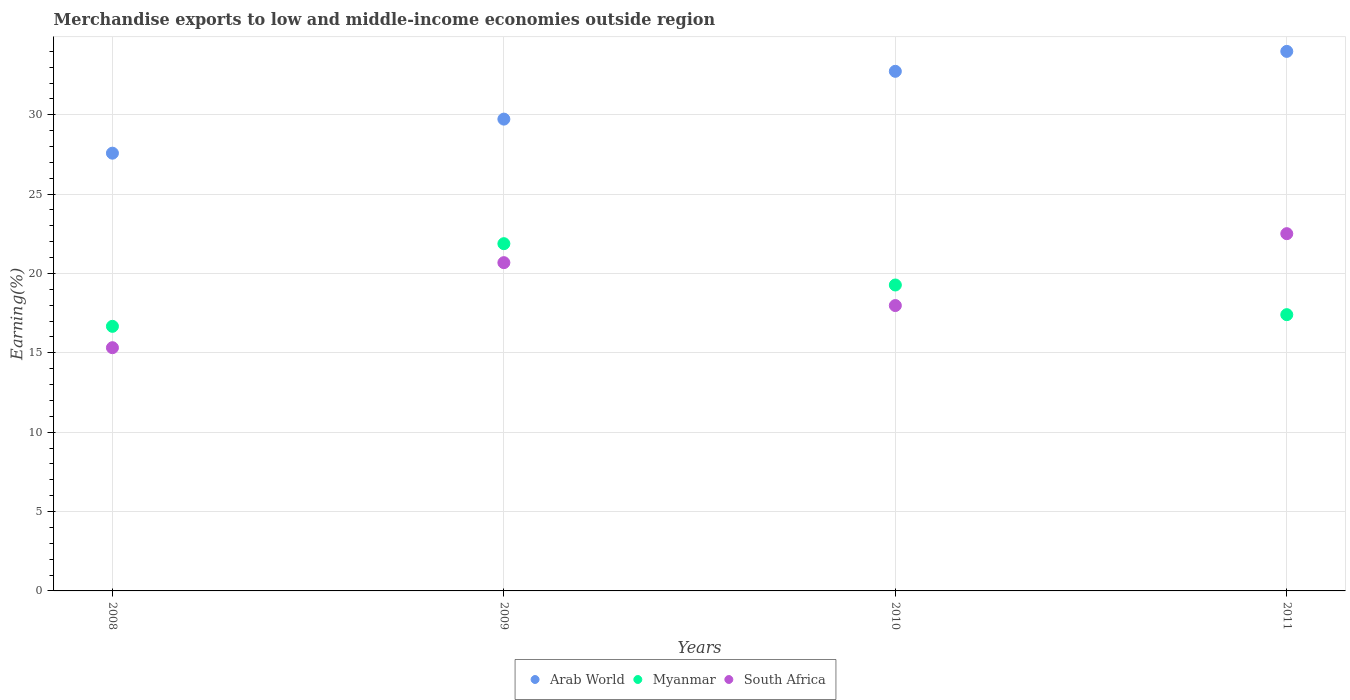Is the number of dotlines equal to the number of legend labels?
Give a very brief answer. Yes. What is the percentage of amount earned from merchandise exports in Myanmar in 2011?
Make the answer very short. 17.41. Across all years, what is the maximum percentage of amount earned from merchandise exports in Arab World?
Your answer should be compact. 33.99. Across all years, what is the minimum percentage of amount earned from merchandise exports in Myanmar?
Offer a terse response. 16.67. In which year was the percentage of amount earned from merchandise exports in Arab World minimum?
Your response must be concise. 2008. What is the total percentage of amount earned from merchandise exports in Arab World in the graph?
Ensure brevity in your answer.  124.03. What is the difference between the percentage of amount earned from merchandise exports in Myanmar in 2009 and that in 2010?
Offer a terse response. 2.6. What is the difference between the percentage of amount earned from merchandise exports in South Africa in 2009 and the percentage of amount earned from merchandise exports in Arab World in 2008?
Make the answer very short. -6.9. What is the average percentage of amount earned from merchandise exports in Arab World per year?
Provide a succinct answer. 31.01. In the year 2010, what is the difference between the percentage of amount earned from merchandise exports in Myanmar and percentage of amount earned from merchandise exports in Arab World?
Ensure brevity in your answer.  -13.46. What is the ratio of the percentage of amount earned from merchandise exports in Arab World in 2008 to that in 2009?
Provide a short and direct response. 0.93. What is the difference between the highest and the second highest percentage of amount earned from merchandise exports in Arab World?
Your response must be concise. 1.26. What is the difference between the highest and the lowest percentage of amount earned from merchandise exports in Arab World?
Provide a succinct answer. 6.41. In how many years, is the percentage of amount earned from merchandise exports in Arab World greater than the average percentage of amount earned from merchandise exports in Arab World taken over all years?
Give a very brief answer. 2. Is the sum of the percentage of amount earned from merchandise exports in Myanmar in 2008 and 2009 greater than the maximum percentage of amount earned from merchandise exports in Arab World across all years?
Provide a succinct answer. Yes. Is it the case that in every year, the sum of the percentage of amount earned from merchandise exports in Arab World and percentage of amount earned from merchandise exports in South Africa  is greater than the percentage of amount earned from merchandise exports in Myanmar?
Offer a very short reply. Yes. Is the percentage of amount earned from merchandise exports in South Africa strictly greater than the percentage of amount earned from merchandise exports in Myanmar over the years?
Provide a succinct answer. No. Is the percentage of amount earned from merchandise exports in Arab World strictly less than the percentage of amount earned from merchandise exports in South Africa over the years?
Your response must be concise. No. How many dotlines are there?
Make the answer very short. 3. What is the difference between two consecutive major ticks on the Y-axis?
Offer a terse response. 5. Are the values on the major ticks of Y-axis written in scientific E-notation?
Give a very brief answer. No. Does the graph contain grids?
Ensure brevity in your answer.  Yes. Where does the legend appear in the graph?
Your answer should be very brief. Bottom center. How are the legend labels stacked?
Make the answer very short. Horizontal. What is the title of the graph?
Give a very brief answer. Merchandise exports to low and middle-income economies outside region. Does "Namibia" appear as one of the legend labels in the graph?
Provide a short and direct response. No. What is the label or title of the Y-axis?
Your answer should be compact. Earning(%). What is the Earning(%) in Arab World in 2008?
Your response must be concise. 27.58. What is the Earning(%) of Myanmar in 2008?
Offer a terse response. 16.67. What is the Earning(%) of South Africa in 2008?
Your answer should be very brief. 15.32. What is the Earning(%) of Arab World in 2009?
Keep it short and to the point. 29.72. What is the Earning(%) in Myanmar in 2009?
Your answer should be very brief. 21.88. What is the Earning(%) of South Africa in 2009?
Offer a very short reply. 20.68. What is the Earning(%) of Arab World in 2010?
Keep it short and to the point. 32.74. What is the Earning(%) in Myanmar in 2010?
Keep it short and to the point. 19.27. What is the Earning(%) in South Africa in 2010?
Give a very brief answer. 17.98. What is the Earning(%) in Arab World in 2011?
Offer a very short reply. 33.99. What is the Earning(%) in Myanmar in 2011?
Provide a succinct answer. 17.41. What is the Earning(%) of South Africa in 2011?
Make the answer very short. 22.51. Across all years, what is the maximum Earning(%) of Arab World?
Your answer should be compact. 33.99. Across all years, what is the maximum Earning(%) in Myanmar?
Provide a succinct answer. 21.88. Across all years, what is the maximum Earning(%) of South Africa?
Offer a terse response. 22.51. Across all years, what is the minimum Earning(%) in Arab World?
Make the answer very short. 27.58. Across all years, what is the minimum Earning(%) of Myanmar?
Make the answer very short. 16.67. Across all years, what is the minimum Earning(%) in South Africa?
Your answer should be compact. 15.32. What is the total Earning(%) in Arab World in the graph?
Your answer should be compact. 124.03. What is the total Earning(%) of Myanmar in the graph?
Give a very brief answer. 75.23. What is the total Earning(%) in South Africa in the graph?
Offer a very short reply. 76.49. What is the difference between the Earning(%) in Arab World in 2008 and that in 2009?
Your response must be concise. -2.15. What is the difference between the Earning(%) of Myanmar in 2008 and that in 2009?
Give a very brief answer. -5.21. What is the difference between the Earning(%) in South Africa in 2008 and that in 2009?
Your answer should be very brief. -5.36. What is the difference between the Earning(%) in Arab World in 2008 and that in 2010?
Offer a terse response. -5.16. What is the difference between the Earning(%) of Myanmar in 2008 and that in 2010?
Offer a terse response. -2.6. What is the difference between the Earning(%) in South Africa in 2008 and that in 2010?
Provide a succinct answer. -2.66. What is the difference between the Earning(%) of Arab World in 2008 and that in 2011?
Make the answer very short. -6.41. What is the difference between the Earning(%) in Myanmar in 2008 and that in 2011?
Ensure brevity in your answer.  -0.74. What is the difference between the Earning(%) in South Africa in 2008 and that in 2011?
Provide a short and direct response. -7.18. What is the difference between the Earning(%) of Arab World in 2009 and that in 2010?
Your response must be concise. -3.01. What is the difference between the Earning(%) of Myanmar in 2009 and that in 2010?
Your response must be concise. 2.6. What is the difference between the Earning(%) in South Africa in 2009 and that in 2010?
Your answer should be compact. 2.7. What is the difference between the Earning(%) in Arab World in 2009 and that in 2011?
Give a very brief answer. -4.27. What is the difference between the Earning(%) of Myanmar in 2009 and that in 2011?
Offer a very short reply. 4.47. What is the difference between the Earning(%) of South Africa in 2009 and that in 2011?
Offer a terse response. -1.83. What is the difference between the Earning(%) of Arab World in 2010 and that in 2011?
Make the answer very short. -1.26. What is the difference between the Earning(%) of Myanmar in 2010 and that in 2011?
Offer a very short reply. 1.87. What is the difference between the Earning(%) of South Africa in 2010 and that in 2011?
Make the answer very short. -4.53. What is the difference between the Earning(%) of Arab World in 2008 and the Earning(%) of Myanmar in 2009?
Ensure brevity in your answer.  5.7. What is the difference between the Earning(%) of Arab World in 2008 and the Earning(%) of South Africa in 2009?
Make the answer very short. 6.9. What is the difference between the Earning(%) of Myanmar in 2008 and the Earning(%) of South Africa in 2009?
Keep it short and to the point. -4.01. What is the difference between the Earning(%) of Arab World in 2008 and the Earning(%) of Myanmar in 2010?
Your answer should be very brief. 8.3. What is the difference between the Earning(%) in Arab World in 2008 and the Earning(%) in South Africa in 2010?
Ensure brevity in your answer.  9.6. What is the difference between the Earning(%) of Myanmar in 2008 and the Earning(%) of South Africa in 2010?
Your response must be concise. -1.31. What is the difference between the Earning(%) in Arab World in 2008 and the Earning(%) in Myanmar in 2011?
Your answer should be very brief. 10.17. What is the difference between the Earning(%) in Arab World in 2008 and the Earning(%) in South Africa in 2011?
Make the answer very short. 5.07. What is the difference between the Earning(%) in Myanmar in 2008 and the Earning(%) in South Africa in 2011?
Your answer should be very brief. -5.84. What is the difference between the Earning(%) in Arab World in 2009 and the Earning(%) in Myanmar in 2010?
Your answer should be very brief. 10.45. What is the difference between the Earning(%) in Arab World in 2009 and the Earning(%) in South Africa in 2010?
Make the answer very short. 11.75. What is the difference between the Earning(%) in Myanmar in 2009 and the Earning(%) in South Africa in 2010?
Offer a very short reply. 3.9. What is the difference between the Earning(%) of Arab World in 2009 and the Earning(%) of Myanmar in 2011?
Offer a terse response. 12.32. What is the difference between the Earning(%) of Arab World in 2009 and the Earning(%) of South Africa in 2011?
Keep it short and to the point. 7.22. What is the difference between the Earning(%) in Myanmar in 2009 and the Earning(%) in South Africa in 2011?
Your answer should be compact. -0.63. What is the difference between the Earning(%) of Arab World in 2010 and the Earning(%) of Myanmar in 2011?
Ensure brevity in your answer.  15.33. What is the difference between the Earning(%) of Arab World in 2010 and the Earning(%) of South Africa in 2011?
Give a very brief answer. 10.23. What is the difference between the Earning(%) in Myanmar in 2010 and the Earning(%) in South Africa in 2011?
Keep it short and to the point. -3.23. What is the average Earning(%) of Arab World per year?
Provide a short and direct response. 31.01. What is the average Earning(%) in Myanmar per year?
Your answer should be very brief. 18.81. What is the average Earning(%) in South Africa per year?
Offer a very short reply. 19.12. In the year 2008, what is the difference between the Earning(%) in Arab World and Earning(%) in Myanmar?
Offer a terse response. 10.91. In the year 2008, what is the difference between the Earning(%) of Arab World and Earning(%) of South Africa?
Your answer should be compact. 12.26. In the year 2008, what is the difference between the Earning(%) of Myanmar and Earning(%) of South Africa?
Provide a succinct answer. 1.35. In the year 2009, what is the difference between the Earning(%) of Arab World and Earning(%) of Myanmar?
Give a very brief answer. 7.85. In the year 2009, what is the difference between the Earning(%) in Arab World and Earning(%) in South Africa?
Offer a very short reply. 9.04. In the year 2009, what is the difference between the Earning(%) of Myanmar and Earning(%) of South Africa?
Give a very brief answer. 1.2. In the year 2010, what is the difference between the Earning(%) of Arab World and Earning(%) of Myanmar?
Keep it short and to the point. 13.46. In the year 2010, what is the difference between the Earning(%) of Arab World and Earning(%) of South Africa?
Give a very brief answer. 14.76. In the year 2010, what is the difference between the Earning(%) of Myanmar and Earning(%) of South Africa?
Offer a very short reply. 1.3. In the year 2011, what is the difference between the Earning(%) in Arab World and Earning(%) in Myanmar?
Offer a terse response. 16.59. In the year 2011, what is the difference between the Earning(%) of Arab World and Earning(%) of South Africa?
Keep it short and to the point. 11.48. In the year 2011, what is the difference between the Earning(%) of Myanmar and Earning(%) of South Africa?
Provide a succinct answer. -5.1. What is the ratio of the Earning(%) of Arab World in 2008 to that in 2009?
Your answer should be compact. 0.93. What is the ratio of the Earning(%) of Myanmar in 2008 to that in 2009?
Offer a very short reply. 0.76. What is the ratio of the Earning(%) in South Africa in 2008 to that in 2009?
Your response must be concise. 0.74. What is the ratio of the Earning(%) of Arab World in 2008 to that in 2010?
Give a very brief answer. 0.84. What is the ratio of the Earning(%) in Myanmar in 2008 to that in 2010?
Your answer should be compact. 0.86. What is the ratio of the Earning(%) in South Africa in 2008 to that in 2010?
Make the answer very short. 0.85. What is the ratio of the Earning(%) in Arab World in 2008 to that in 2011?
Provide a succinct answer. 0.81. What is the ratio of the Earning(%) of Myanmar in 2008 to that in 2011?
Provide a short and direct response. 0.96. What is the ratio of the Earning(%) in South Africa in 2008 to that in 2011?
Your answer should be very brief. 0.68. What is the ratio of the Earning(%) in Arab World in 2009 to that in 2010?
Provide a short and direct response. 0.91. What is the ratio of the Earning(%) of Myanmar in 2009 to that in 2010?
Ensure brevity in your answer.  1.14. What is the ratio of the Earning(%) of South Africa in 2009 to that in 2010?
Your answer should be compact. 1.15. What is the ratio of the Earning(%) of Arab World in 2009 to that in 2011?
Provide a short and direct response. 0.87. What is the ratio of the Earning(%) in Myanmar in 2009 to that in 2011?
Offer a very short reply. 1.26. What is the ratio of the Earning(%) in South Africa in 2009 to that in 2011?
Your answer should be very brief. 0.92. What is the ratio of the Earning(%) of Arab World in 2010 to that in 2011?
Ensure brevity in your answer.  0.96. What is the ratio of the Earning(%) in Myanmar in 2010 to that in 2011?
Keep it short and to the point. 1.11. What is the ratio of the Earning(%) of South Africa in 2010 to that in 2011?
Provide a short and direct response. 0.8. What is the difference between the highest and the second highest Earning(%) of Arab World?
Your answer should be compact. 1.26. What is the difference between the highest and the second highest Earning(%) of Myanmar?
Ensure brevity in your answer.  2.6. What is the difference between the highest and the second highest Earning(%) in South Africa?
Make the answer very short. 1.83. What is the difference between the highest and the lowest Earning(%) of Arab World?
Your answer should be compact. 6.41. What is the difference between the highest and the lowest Earning(%) in Myanmar?
Give a very brief answer. 5.21. What is the difference between the highest and the lowest Earning(%) in South Africa?
Offer a very short reply. 7.18. 